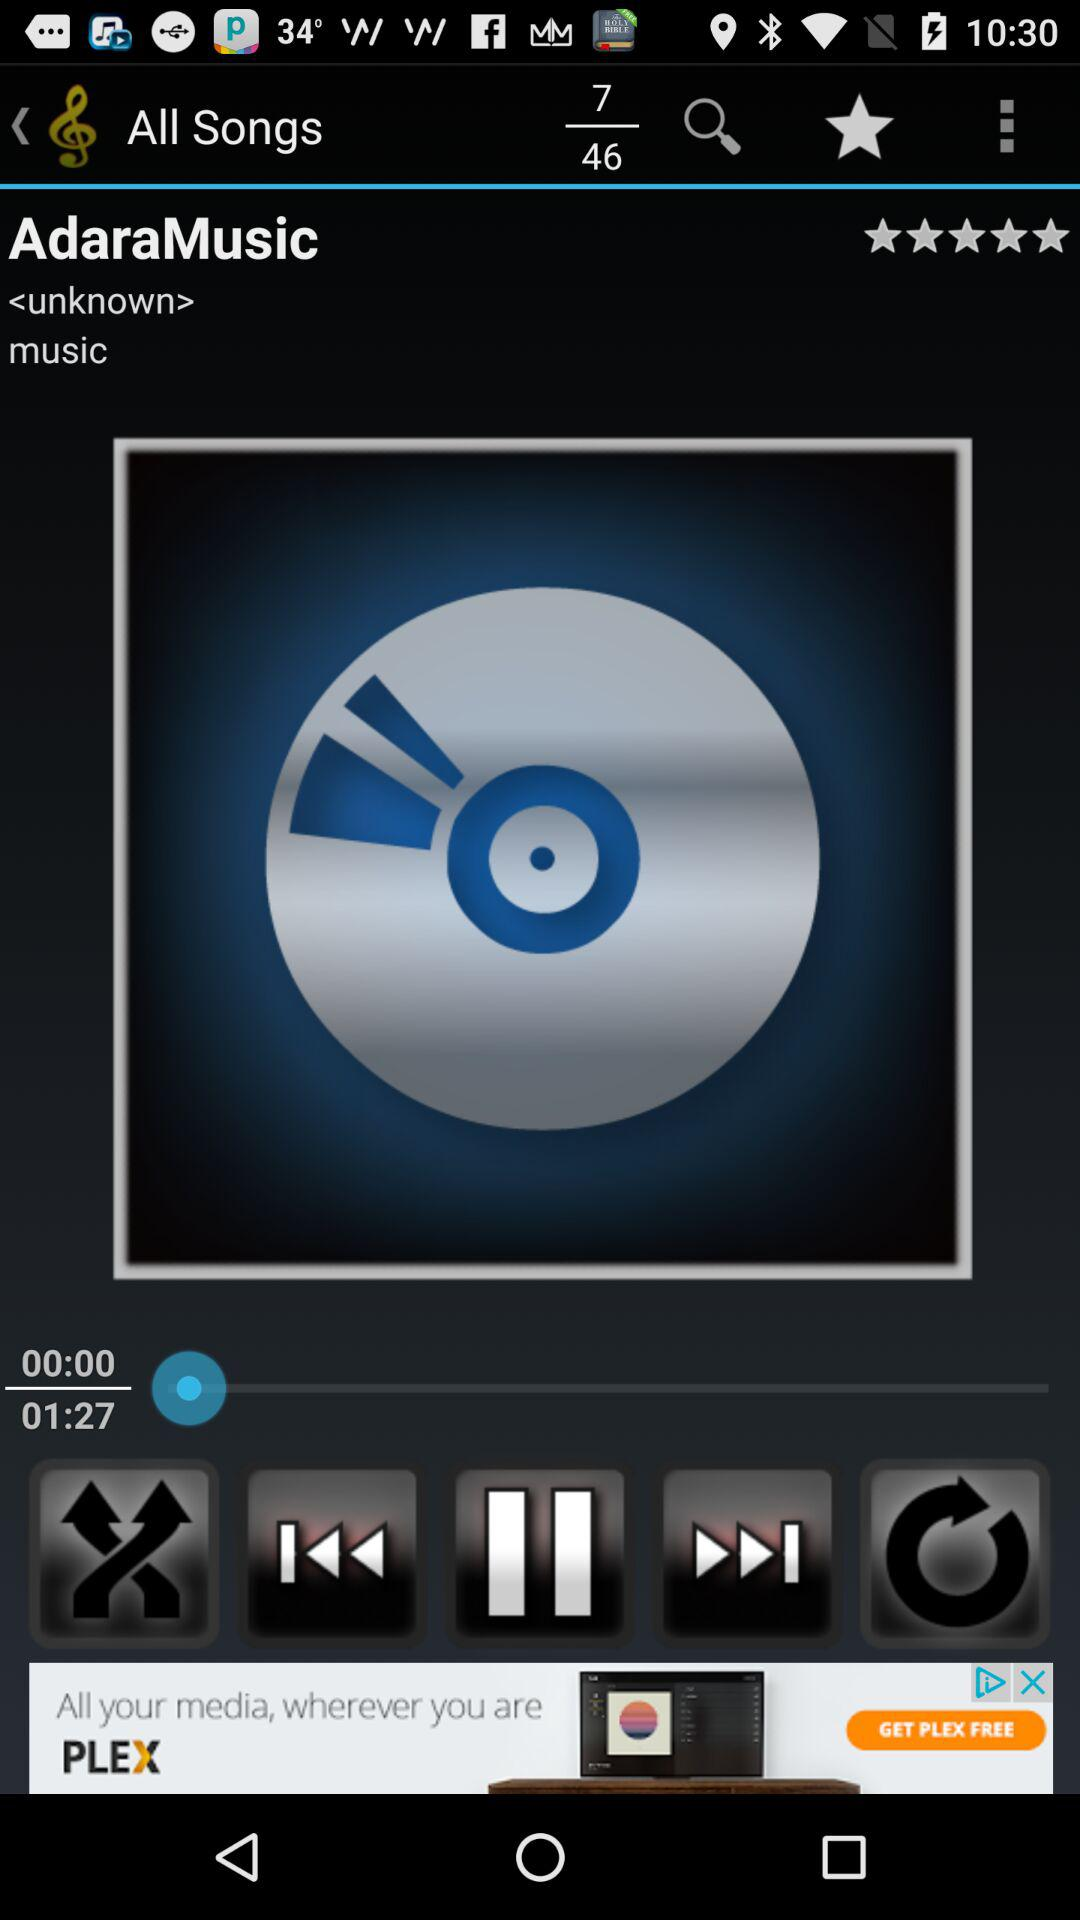Which song is playing right now? The song is "AdaraMusic". 